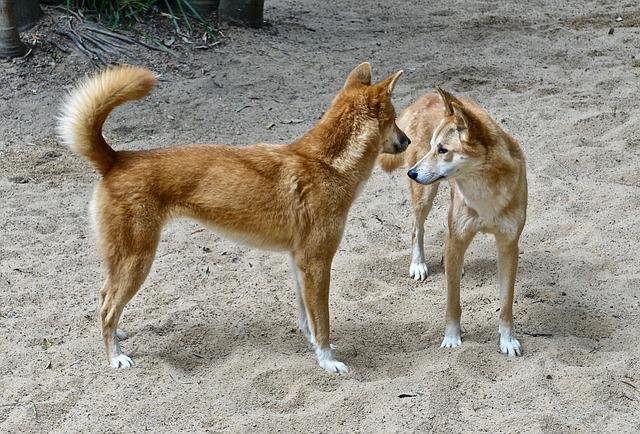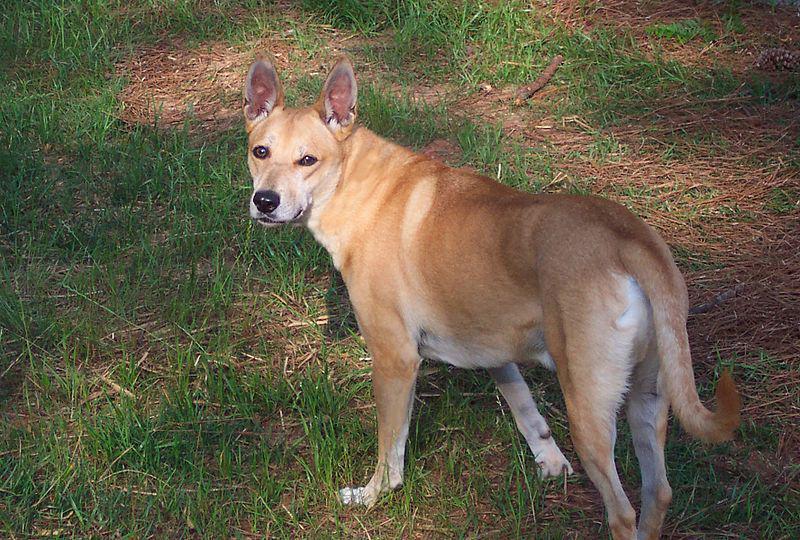The first image is the image on the left, the second image is the image on the right. Assess this claim about the two images: "The left image contains twice the number of dogs as the right image, and at least two dogs in total are standing.". Correct or not? Answer yes or no. Yes. The first image is the image on the left, the second image is the image on the right. Considering the images on both sides, is "The left image contains exactly two wild dogs." valid? Answer yes or no. Yes. 